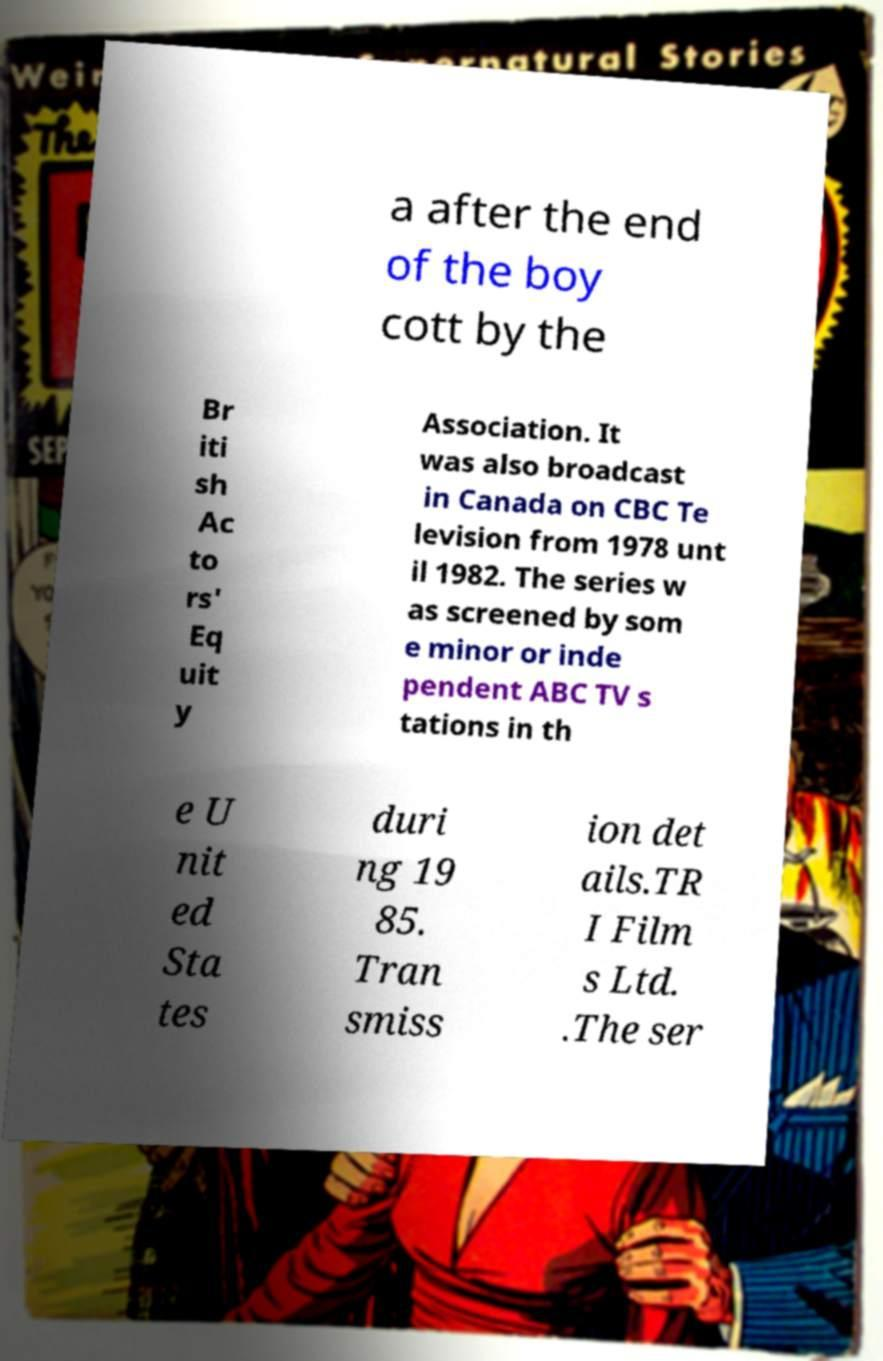There's text embedded in this image that I need extracted. Can you transcribe it verbatim? a after the end of the boy cott by the Br iti sh Ac to rs' Eq uit y Association. It was also broadcast in Canada on CBC Te levision from 1978 unt il 1982. The series w as screened by som e minor or inde pendent ABC TV s tations in th e U nit ed Sta tes duri ng 19 85. Tran smiss ion det ails.TR I Film s Ltd. .The ser 